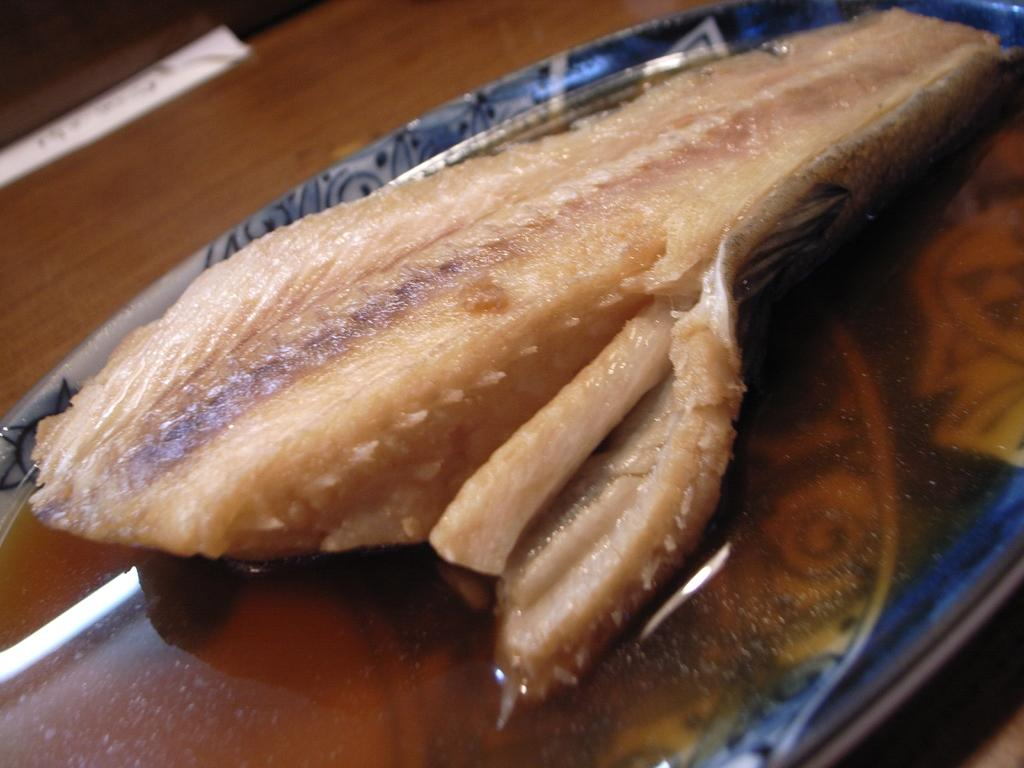What type of food can be seen in the image? There is an edible item and soup in the image. How are the edible item and soup arranged in the image? Both the edible item and soup are placed on a plate. What is the price of the fruit in the image? There is no fruit present in the image, so it is not possible to determine the price. 